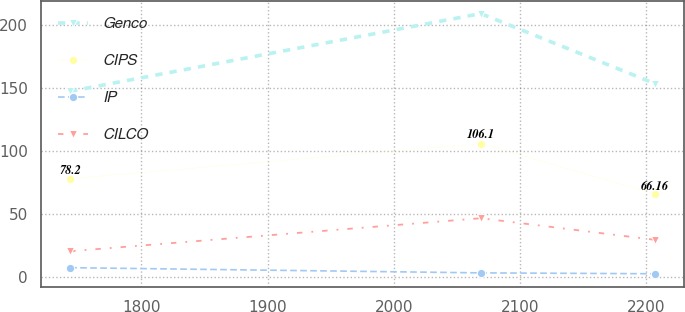<chart> <loc_0><loc_0><loc_500><loc_500><line_chart><ecel><fcel>Genco<fcel>CIPS<fcel>IP<fcel>CILCO<nl><fcel>1743.53<fcel>147.54<fcel>78.2<fcel>7.66<fcel>20.68<nl><fcel>2068.88<fcel>209.15<fcel>106.1<fcel>3.54<fcel>46.88<nl><fcel>2206.64<fcel>153.7<fcel>66.16<fcel>2.83<fcel>29.77<nl></chart> 